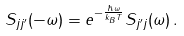<formula> <loc_0><loc_0><loc_500><loc_500>S _ { j j ^ { \prime } } ( - \omega ) = e ^ { - \frac { \hbar { \omega } } { k _ { B } T } } S _ { j ^ { \prime } j } ( \omega ) \, .</formula> 